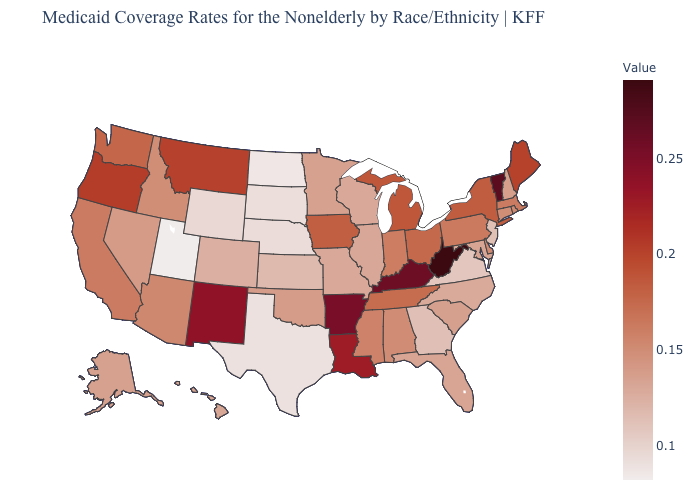Does the map have missing data?
Keep it brief. No. Among the states that border North Dakota , which have the lowest value?
Give a very brief answer. South Dakota. Does New Mexico have the highest value in the West?
Quick response, please. Yes. Among the states that border Kentucky , does Virginia have the lowest value?
Short answer required. Yes. Does the map have missing data?
Write a very short answer. No. Does South Carolina have the highest value in the South?
Concise answer only. No. 